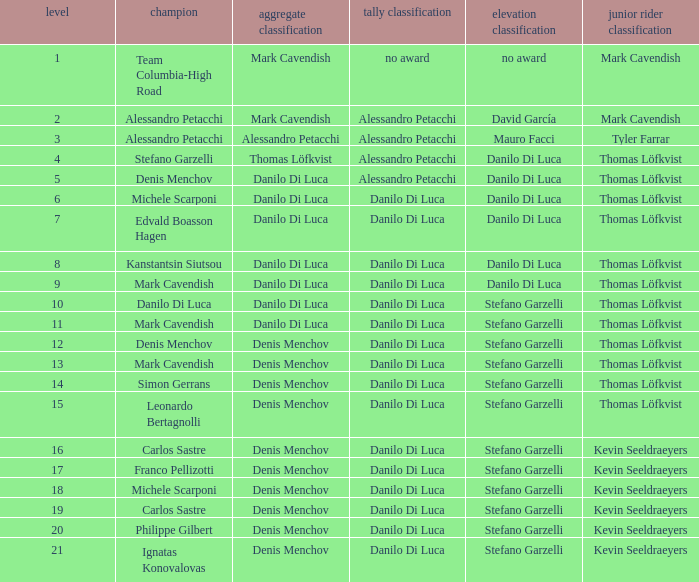When danilo di luca is the winner who is the general classification?  Danilo Di Luca. 